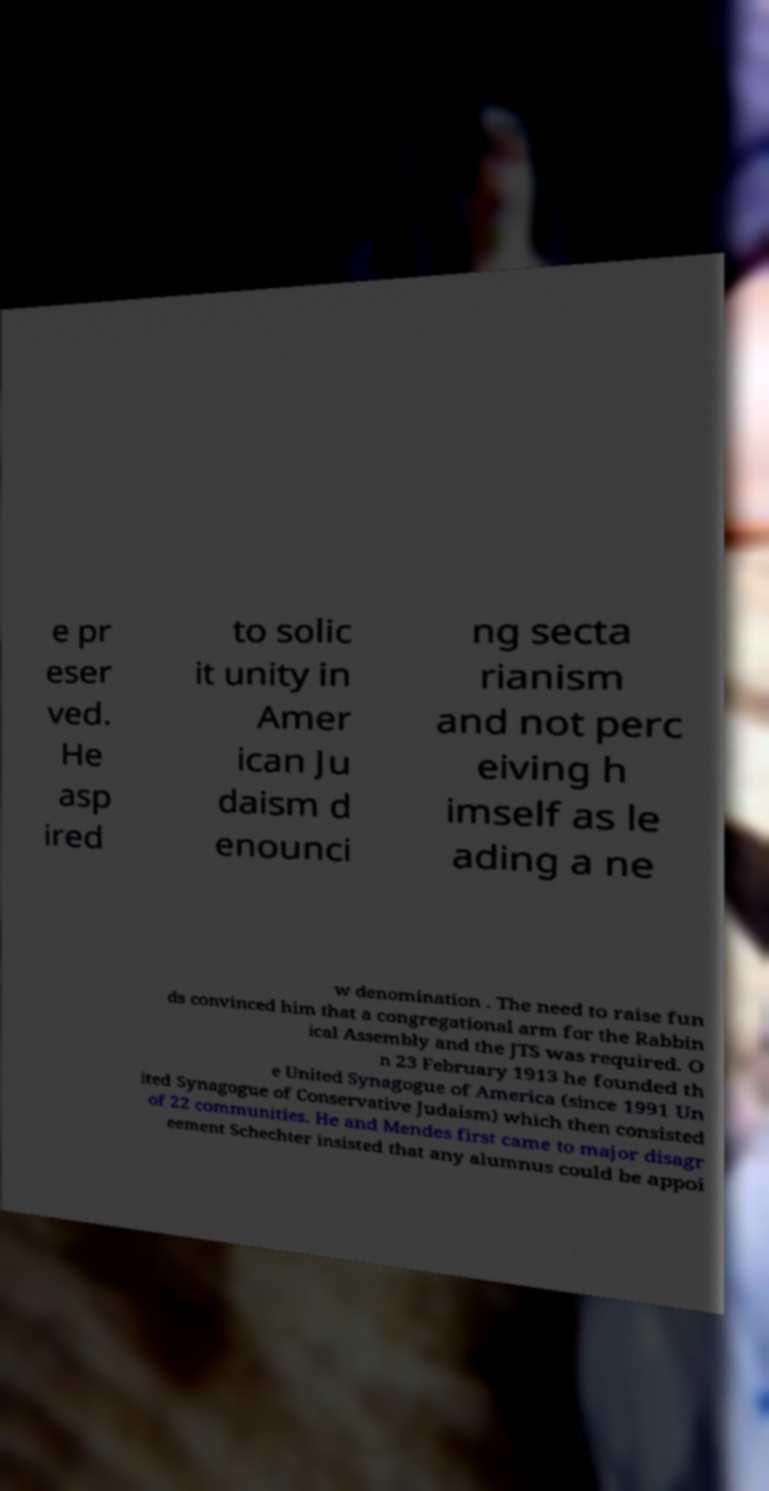Can you accurately transcribe the text from the provided image for me? e pr eser ved. He asp ired to solic it unity in Amer ican Ju daism d enounci ng secta rianism and not perc eiving h imself as le ading a ne w denomination . The need to raise fun ds convinced him that a congregational arm for the Rabbin ical Assembly and the JTS was required. O n 23 February 1913 he founded th e United Synagogue of America (since 1991 Un ited Synagogue of Conservative Judaism) which then consisted of 22 communities. He and Mendes first came to major disagr eement Schechter insisted that any alumnus could be appoi 